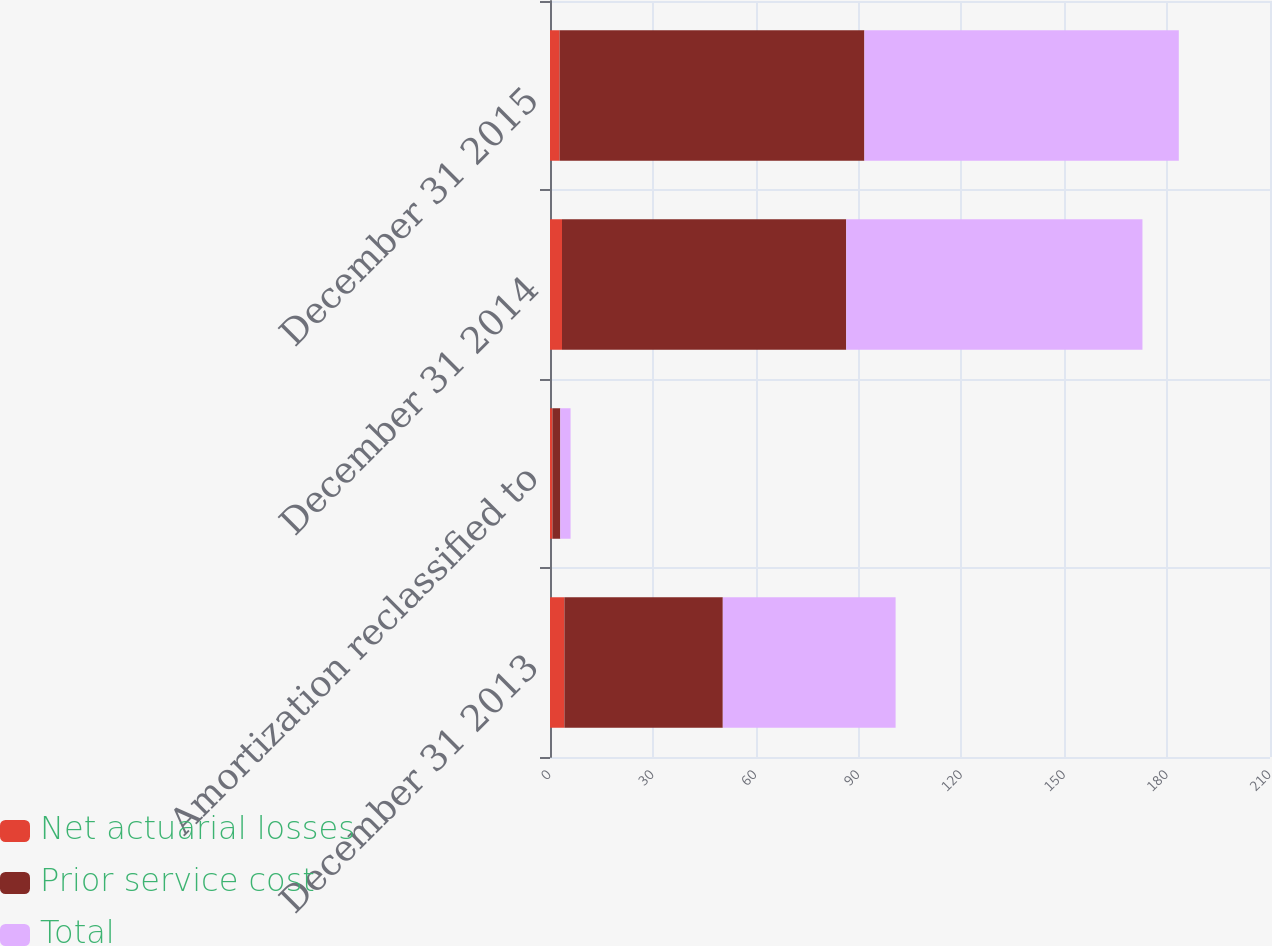<chart> <loc_0><loc_0><loc_500><loc_500><stacked_bar_chart><ecel><fcel>December 31 2013<fcel>Amortization reclassified to<fcel>December 31 2014<fcel>December 31 2015<nl><fcel>Net actuarial losses<fcel>4.2<fcel>0.7<fcel>3.5<fcel>2.8<nl><fcel>Prior service cost<fcel>46.2<fcel>2.3<fcel>82.9<fcel>88.9<nl><fcel>Total<fcel>50.4<fcel>3<fcel>86.4<fcel>91.7<nl></chart> 